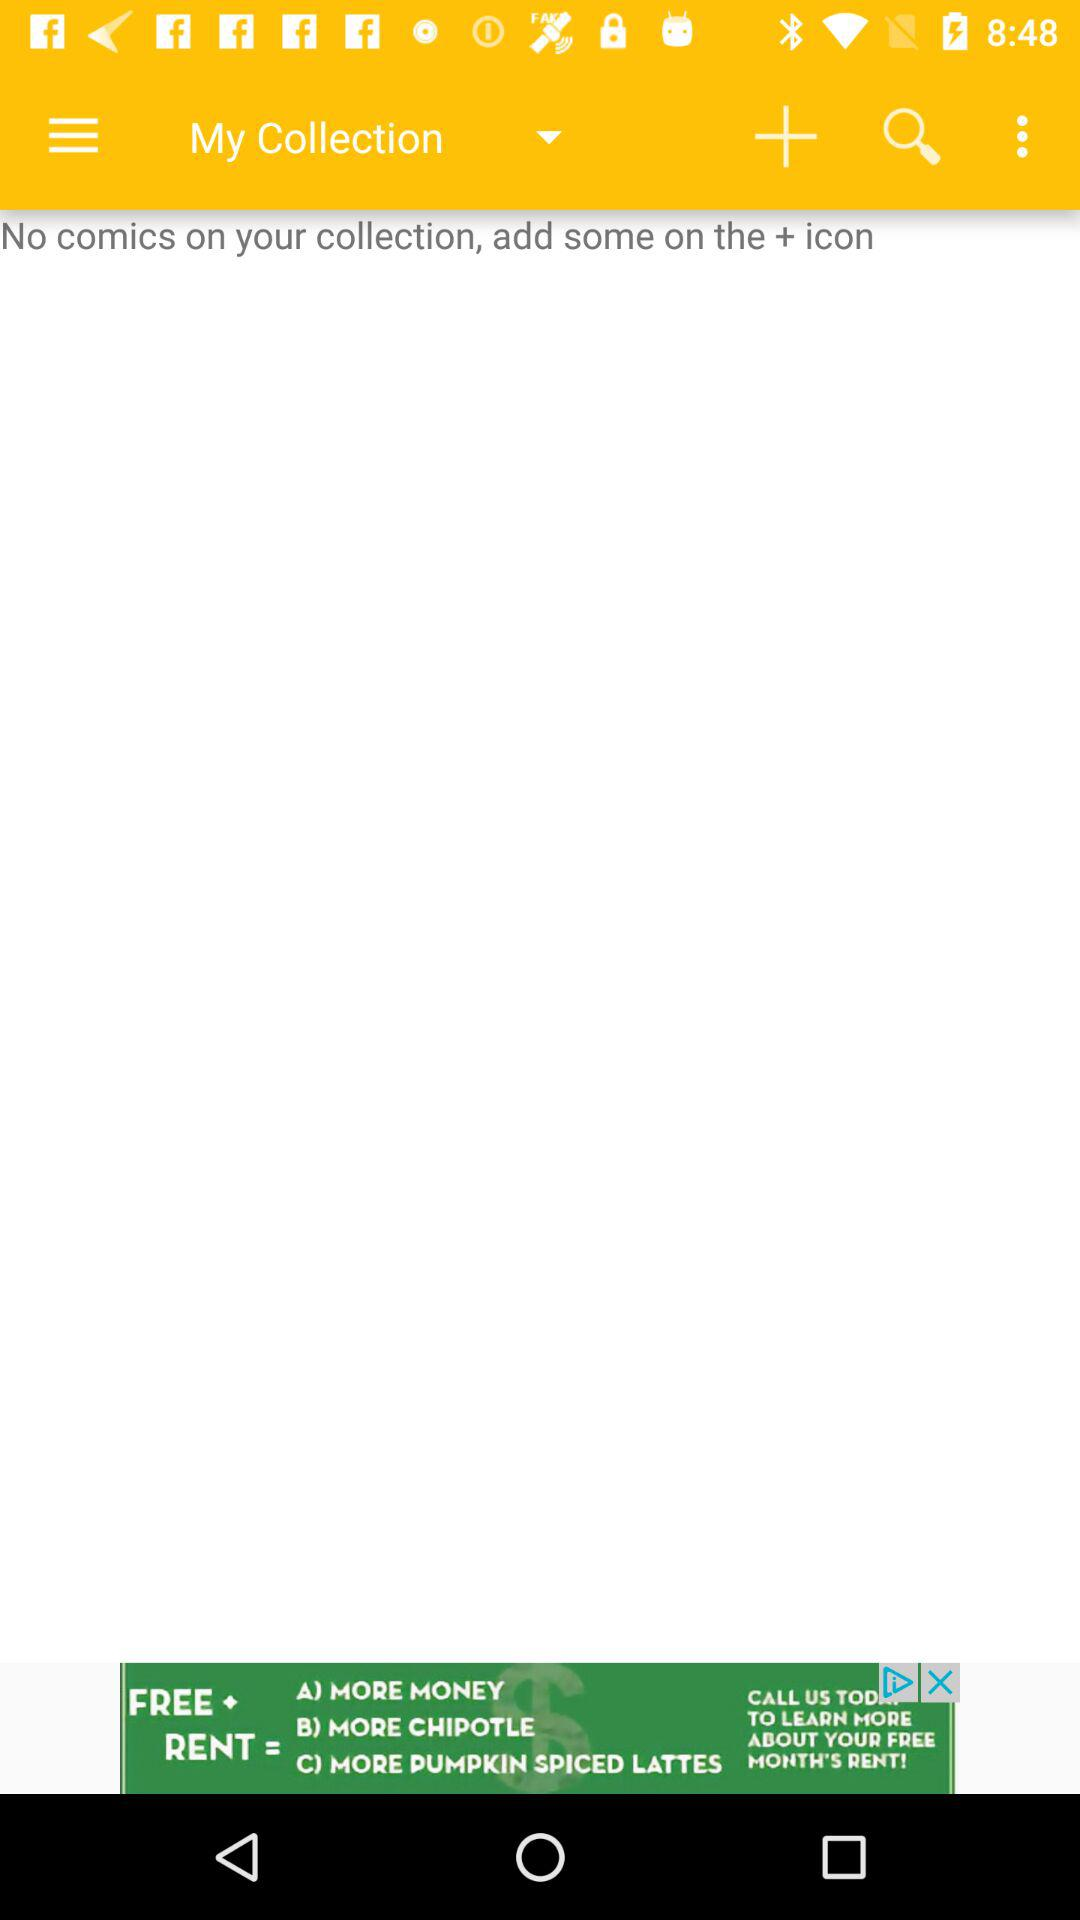How many comics are in my collection?
Answer the question using a single word or phrase. 0 